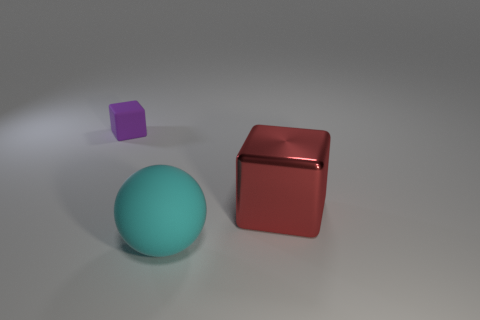What number of cyan balls have the same size as the shiny cube? 1 